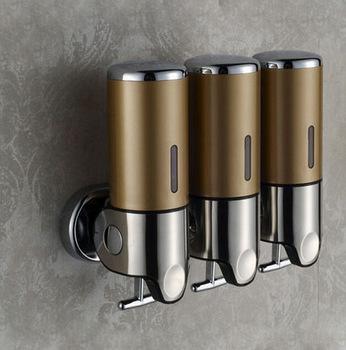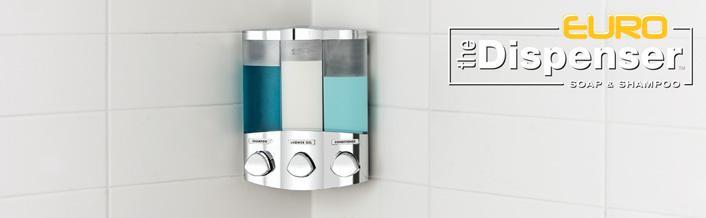The first image is the image on the left, the second image is the image on the right. For the images shown, is this caption "In the right image three dispensers have a silvered colored solid top." true? Answer yes or no. No. 